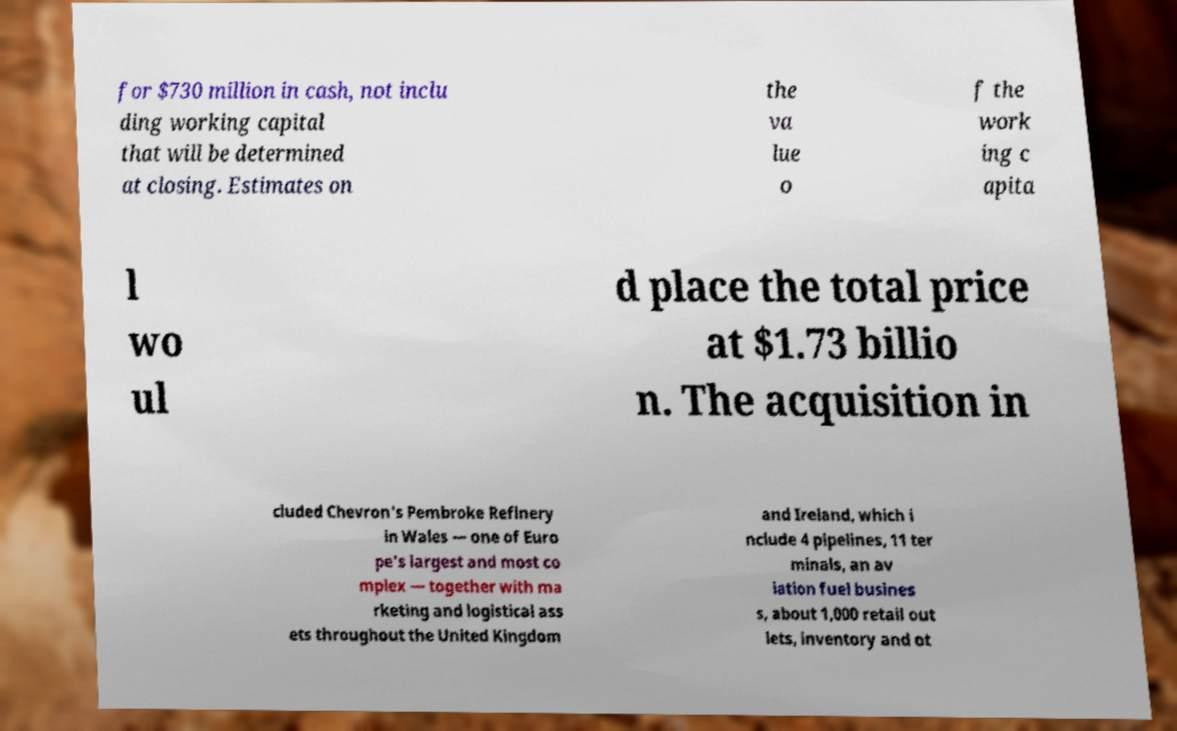Could you assist in decoding the text presented in this image and type it out clearly? for $730 million in cash, not inclu ding working capital that will be determined at closing. Estimates on the va lue o f the work ing c apita l wo ul d place the total price at $1.73 billio n. The acquisition in cluded Chevron's Pembroke Refinery in Wales — one of Euro pe's largest and most co mplex — together with ma rketing and logistical ass ets throughout the United Kingdom and Ireland, which i nclude 4 pipelines, 11 ter minals, an av iation fuel busines s, about 1,000 retail out lets, inventory and ot 